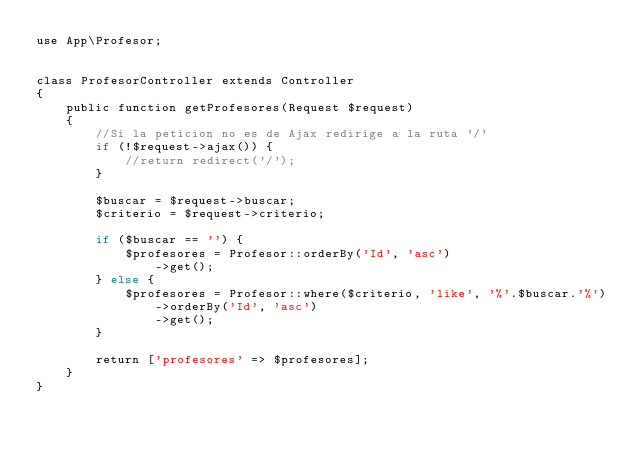Convert code to text. <code><loc_0><loc_0><loc_500><loc_500><_PHP_>use App\Profesor;


class ProfesorController extends Controller
{
    public function getProfesores(Request $request)
    {
        //Si la peticion no es de Ajax redirige a la ruta '/'
        if (!$request->ajax()) {
            //return redirect('/');
        }

        $buscar = $request->buscar;
        $criterio = $request->criterio;

        if ($buscar == '') {
            $profesores = Profesor::orderBy('Id', 'asc')
                ->get();
        } else {
            $profesores = Profesor::where($criterio, 'like', '%'.$buscar.'%')
                ->orderBy('Id', 'asc')
                ->get();         
        }        

        return ['profesores' => $profesores];
    }
}
</code> 